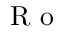Convert formula to latex. <formula><loc_0><loc_0><loc_500><loc_500>R o</formula> 